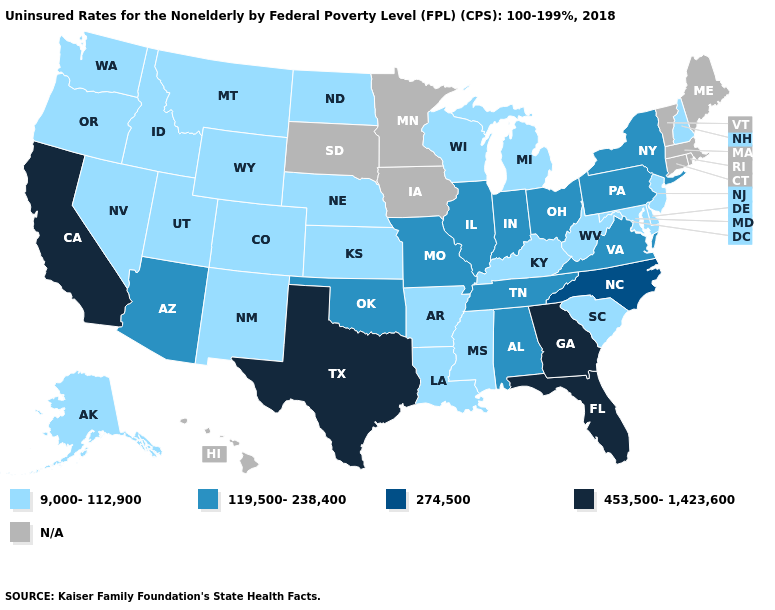Name the states that have a value in the range 9,000-112,900?
Concise answer only. Alaska, Arkansas, Colorado, Delaware, Idaho, Kansas, Kentucky, Louisiana, Maryland, Michigan, Mississippi, Montana, Nebraska, Nevada, New Hampshire, New Jersey, New Mexico, North Dakota, Oregon, South Carolina, Utah, Washington, West Virginia, Wisconsin, Wyoming. Does Idaho have the lowest value in the West?
Keep it brief. Yes. Does California have the lowest value in the West?
Give a very brief answer. No. Name the states that have a value in the range 119,500-238,400?
Quick response, please. Alabama, Arizona, Illinois, Indiana, Missouri, New York, Ohio, Oklahoma, Pennsylvania, Tennessee, Virginia. What is the value of Michigan?
Short answer required. 9,000-112,900. Does the map have missing data?
Give a very brief answer. Yes. Name the states that have a value in the range 9,000-112,900?
Answer briefly. Alaska, Arkansas, Colorado, Delaware, Idaho, Kansas, Kentucky, Louisiana, Maryland, Michigan, Mississippi, Montana, Nebraska, Nevada, New Hampshire, New Jersey, New Mexico, North Dakota, Oregon, South Carolina, Utah, Washington, West Virginia, Wisconsin, Wyoming. Does Oklahoma have the lowest value in the South?
Quick response, please. No. Does the first symbol in the legend represent the smallest category?
Concise answer only. Yes. Name the states that have a value in the range 9,000-112,900?
Give a very brief answer. Alaska, Arkansas, Colorado, Delaware, Idaho, Kansas, Kentucky, Louisiana, Maryland, Michigan, Mississippi, Montana, Nebraska, Nevada, New Hampshire, New Jersey, New Mexico, North Dakota, Oregon, South Carolina, Utah, Washington, West Virginia, Wisconsin, Wyoming. What is the highest value in the Northeast ?
Write a very short answer. 119,500-238,400. What is the value of Virginia?
Give a very brief answer. 119,500-238,400. What is the lowest value in the Northeast?
Keep it brief. 9,000-112,900. Name the states that have a value in the range 9,000-112,900?
Answer briefly. Alaska, Arkansas, Colorado, Delaware, Idaho, Kansas, Kentucky, Louisiana, Maryland, Michigan, Mississippi, Montana, Nebraska, Nevada, New Hampshire, New Jersey, New Mexico, North Dakota, Oregon, South Carolina, Utah, Washington, West Virginia, Wisconsin, Wyoming. 